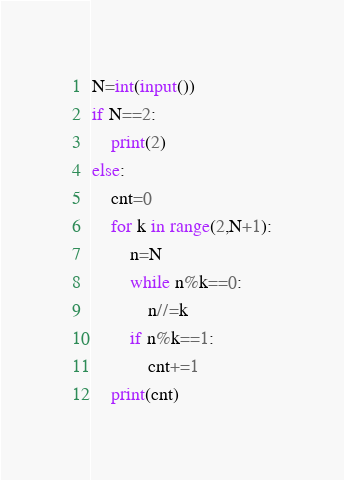<code> <loc_0><loc_0><loc_500><loc_500><_Python_>N=int(input())
if N==2:
    print(2)
else:
    cnt=0
    for k in range(2,N+1):
        n=N
        while n%k==0:
            n//=k
        if n%k==1:
            cnt+=1
    print(cnt)</code> 